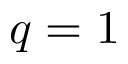<formula> <loc_0><loc_0><loc_500><loc_500>q = 1</formula> 